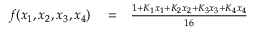<formula> <loc_0><loc_0><loc_500><loc_500>\begin{array} { r l r } { f ( x _ { 1 } , x _ { 2 } , x _ { 3 } , x _ { 4 } ) } & = } & { \frac { 1 + K _ { 1 } x _ { 1 } + K _ { 2 } x _ { 2 } + K _ { 3 } x _ { 3 } + K _ { 4 } x _ { 4 } } { 1 6 } } \end{array}</formula> 